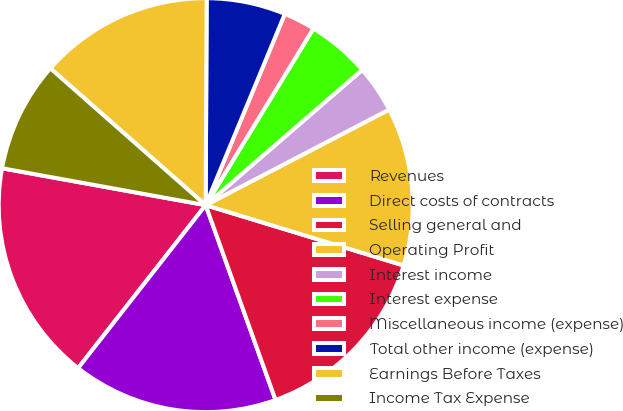Convert chart to OTSL. <chart><loc_0><loc_0><loc_500><loc_500><pie_chart><fcel>Revenues<fcel>Direct costs of contracts<fcel>Selling general and<fcel>Operating Profit<fcel>Interest income<fcel>Interest expense<fcel>Miscellaneous income (expense)<fcel>Total other income (expense)<fcel>Earnings Before Taxes<fcel>Income Tax Expense<nl><fcel>17.28%<fcel>16.05%<fcel>14.81%<fcel>12.35%<fcel>3.7%<fcel>4.94%<fcel>2.47%<fcel>6.17%<fcel>13.58%<fcel>8.64%<nl></chart> 